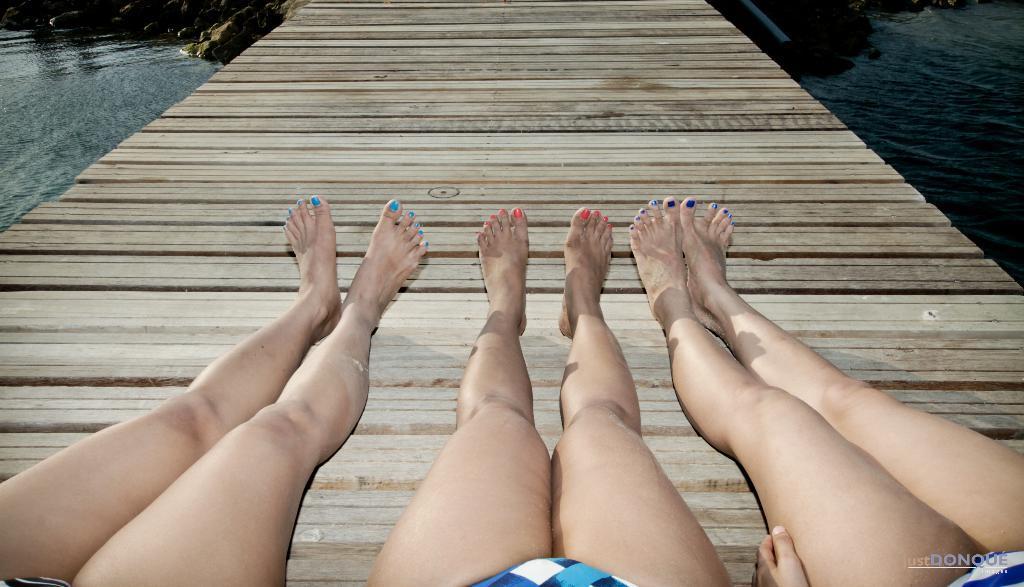Can you describe this image briefly? In this picture there are three people on the wooden floor. At the back there are rocks. At the bottom there is water. 